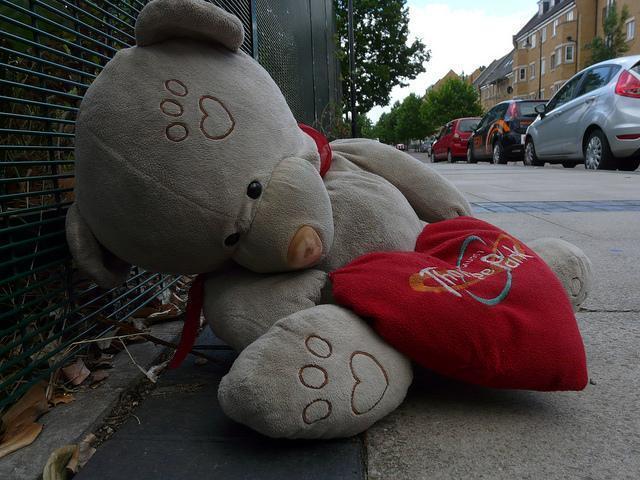How many teddy bears are there?
Give a very brief answer. 1. How many cars are visible?
Give a very brief answer. 2. 